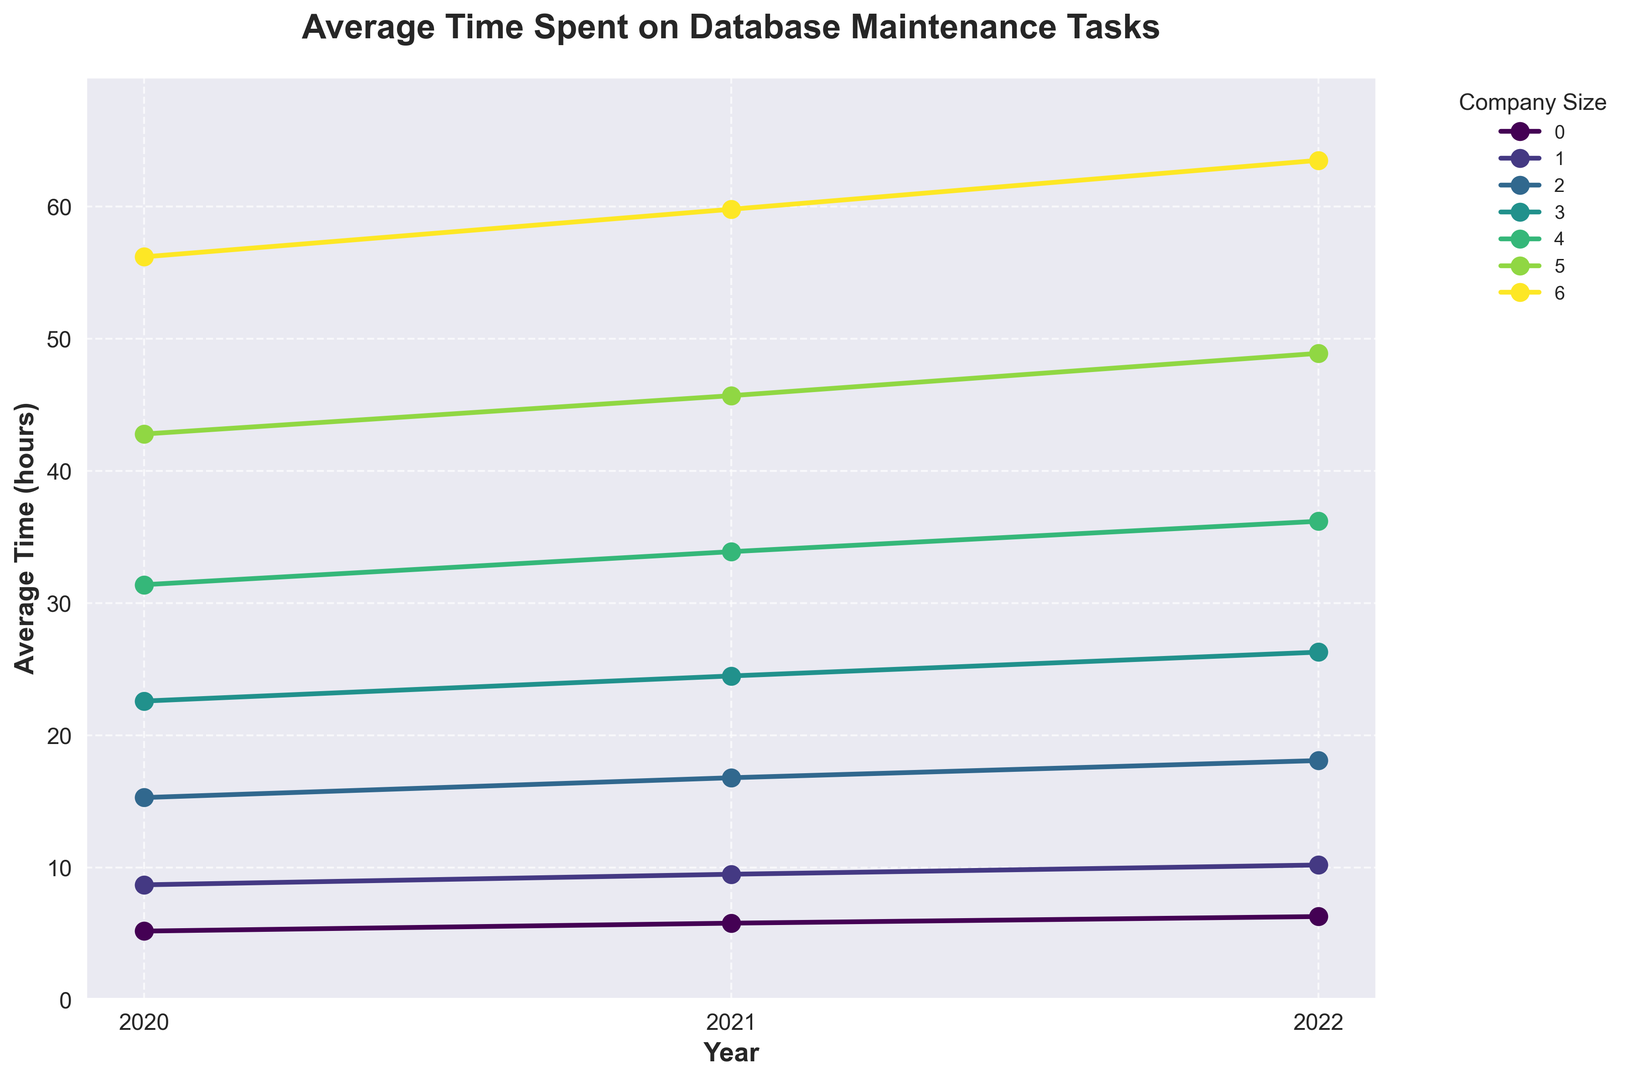What company size experienced the largest increase in average time spent on database maintenance from 2020 to 2022? First, find the values for 2020 and 2022 for each company size. Then, calculate the difference for each group. The differences are: 1-10 employees (6.3 - 5.2 = 1.1), 11-50 employees (10.2 - 8.7 = 1.5), 51-200 employees (18.1 - 15.3 = 2.8), 201-500 employees (26.3 - 22.6 = 3.7), 501-1000 employees (36.2 - 31.4 = 4.8), 1001-5000 employees (48.9 - 42.8 = 6.1), 5001+ employees (63.5 - 56.2 = 7.3). The largest increase is seen in the 5001+ employees group with an increase of 7.3 hours.
Answer: 5001+ employees Which year saw the highest average time spent on database maintenance tasks for the 201-500 employees group? Refer to the values for the 201-500 employees group in 2020, 2021, and 2022, which are 22.6, 24.5, and 26.3 respectively. The highest value is 26.3 in 2022.
Answer: 2022 How does the average time spent on database maintenance in 2022 for companies with 11-50 employees compare to companies with 501-1000 employees? Compare the values for 2022 for both companies: 11-50 employees (10.2) and 501-1000 employees (36.2). The value for 501-1000 employees is higher.
Answer: 501-1000 employees have a higher value What is the overall trend for average time spent on database maintenance tasks for all company sizes over the years? Observe the lines plotted for each company size from 2020 to 2022. All lines show an upward trend, indicating that the average time spent on database maintenance tasks is increasing across all company sizes over the years.
Answer: Upward trend How much more average time did companies with 1001-5000 employees spend on database maintenance in 2021 compared to 2020? Look at the average time for the 1001-5000 employees group in 2020 and 2021: 2020 (42.8) and 2021 (45.7). The difference is 45.7 - 42.8 = 2.9 hours.
Answer: 2.9 hours What is the average increase in time spent on database maintenance from 2020 to 2022 for companies with 51-200 employees? Calculate the increase for the 51-200 employees group from 2020 to 2022: 18.1 - 15.3 = 2.8 hours. Then, divide by the number of years, which is 2: 2.8 / 2 = 1.4 hours.
Answer: 1.4 hours per year 